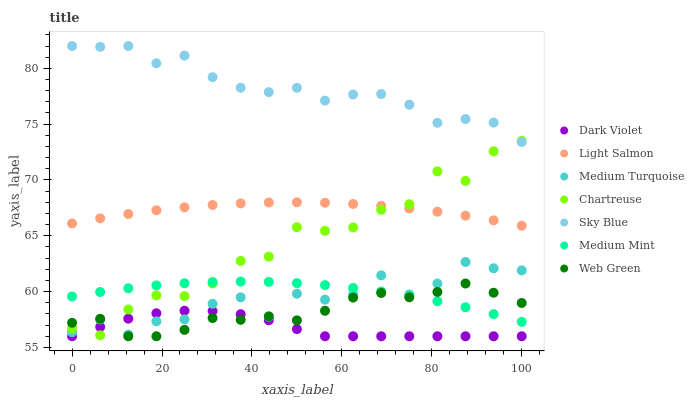Does Dark Violet have the minimum area under the curve?
Answer yes or no. Yes. Does Sky Blue have the maximum area under the curve?
Answer yes or no. Yes. Does Light Salmon have the minimum area under the curve?
Answer yes or no. No. Does Light Salmon have the maximum area under the curve?
Answer yes or no. No. Is Light Salmon the smoothest?
Answer yes or no. Yes. Is Medium Turquoise the roughest?
Answer yes or no. Yes. Is Dark Violet the smoothest?
Answer yes or no. No. Is Dark Violet the roughest?
Answer yes or no. No. Does Dark Violet have the lowest value?
Answer yes or no. Yes. Does Light Salmon have the lowest value?
Answer yes or no. No. Does Sky Blue have the highest value?
Answer yes or no. Yes. Does Light Salmon have the highest value?
Answer yes or no. No. Is Medium Mint less than Sky Blue?
Answer yes or no. Yes. Is Light Salmon greater than Dark Violet?
Answer yes or no. Yes. Does Chartreuse intersect Sky Blue?
Answer yes or no. Yes. Is Chartreuse less than Sky Blue?
Answer yes or no. No. Is Chartreuse greater than Sky Blue?
Answer yes or no. No. Does Medium Mint intersect Sky Blue?
Answer yes or no. No. 